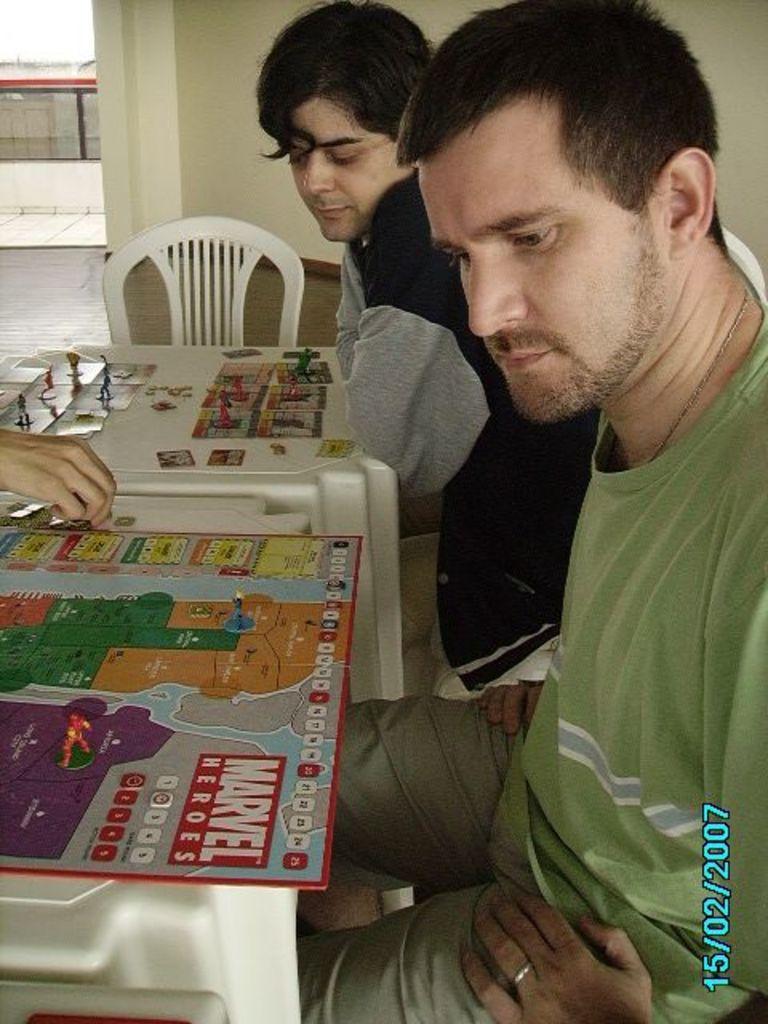In one or two sentences, can you explain what this image depicts? In this image I can see two people and one hand of a person. In the background I can see a chair and two tables. 